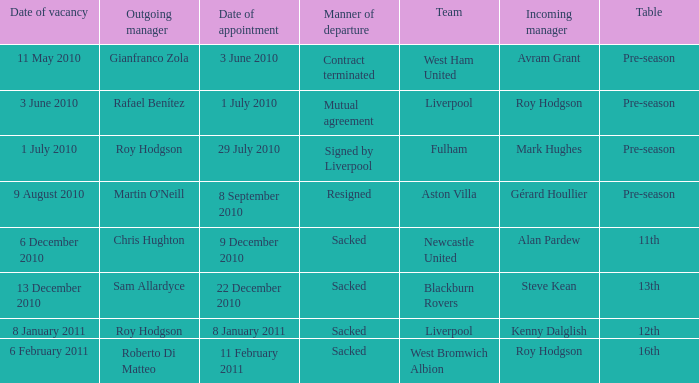What is the date of vacancy for the Liverpool team with a table named pre-season? 3 June 2010. 